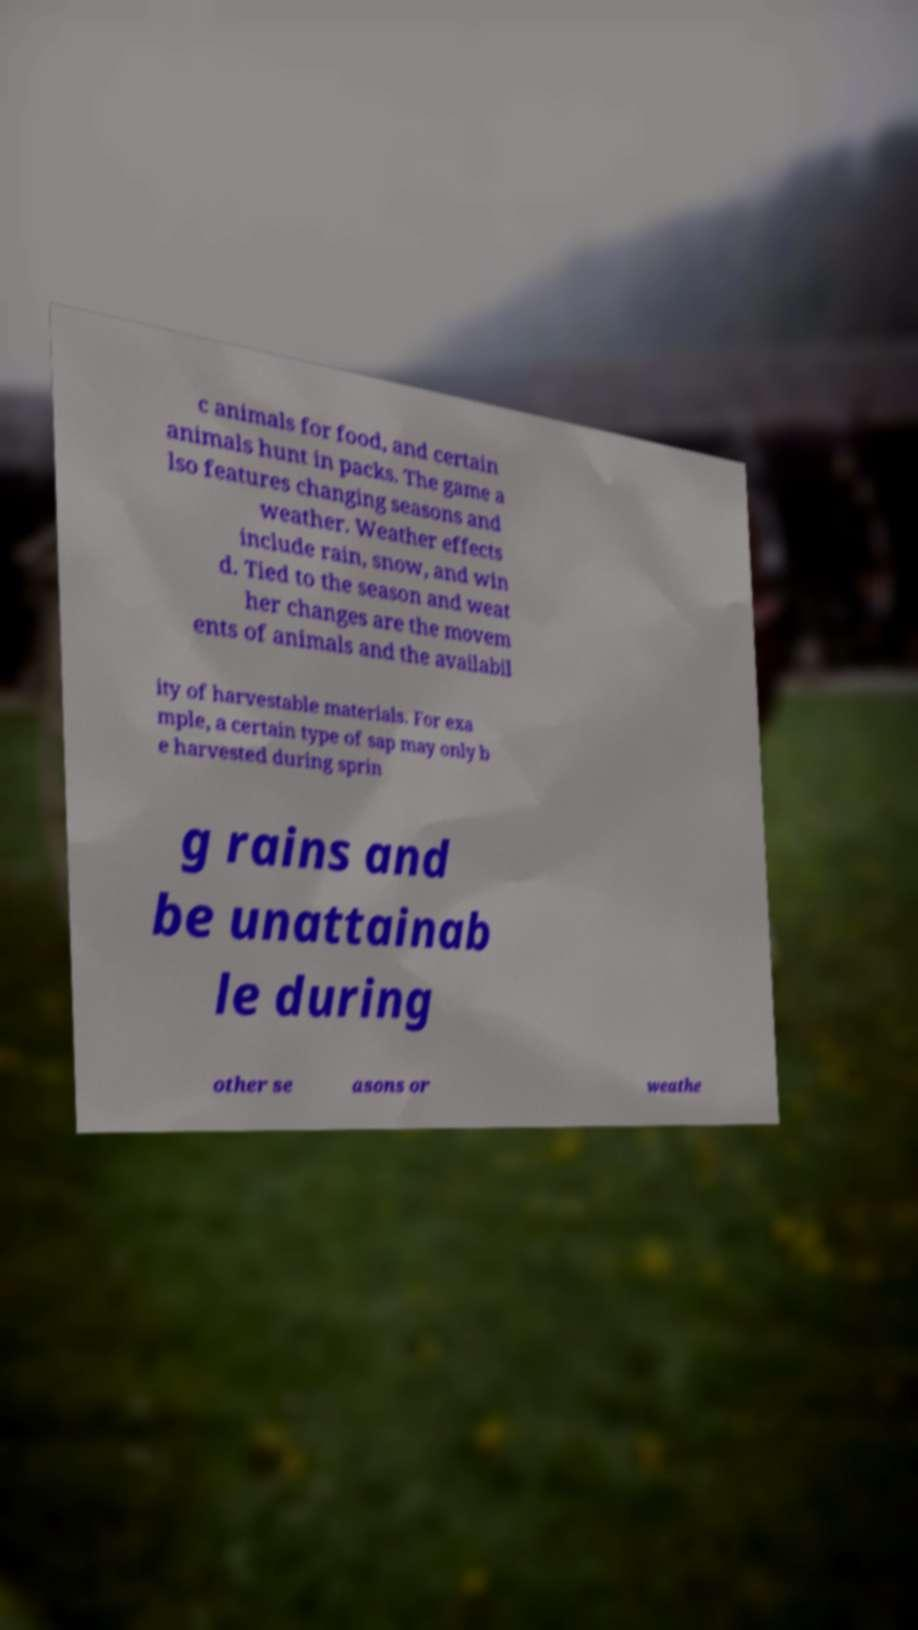Could you extract and type out the text from this image? c animals for food, and certain animals hunt in packs. The game a lso features changing seasons and weather. Weather effects include rain, snow, and win d. Tied to the season and weat her changes are the movem ents of animals and the availabil ity of harvestable materials. For exa mple, a certain type of sap may only b e harvested during sprin g rains and be unattainab le during other se asons or weathe 